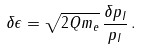<formula> <loc_0><loc_0><loc_500><loc_500>\delta \epsilon = \sqrt { 2 Q m _ { e } } \, \frac { \delta p _ { I } } { p _ { I } } \, .</formula> 